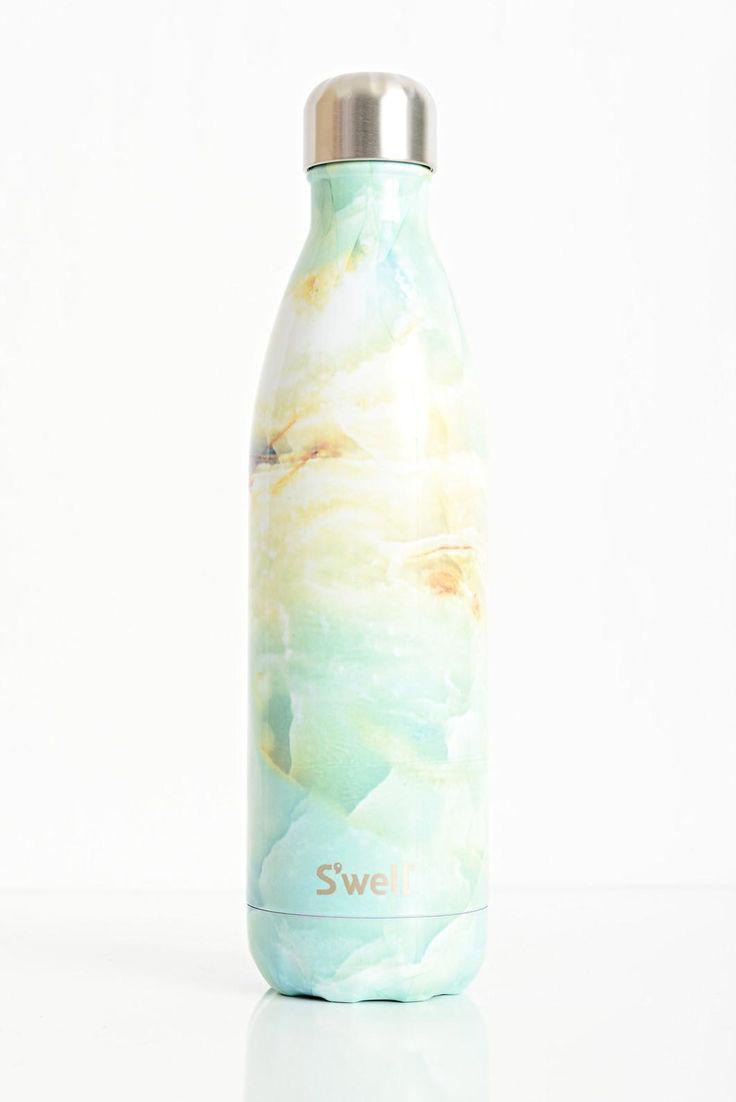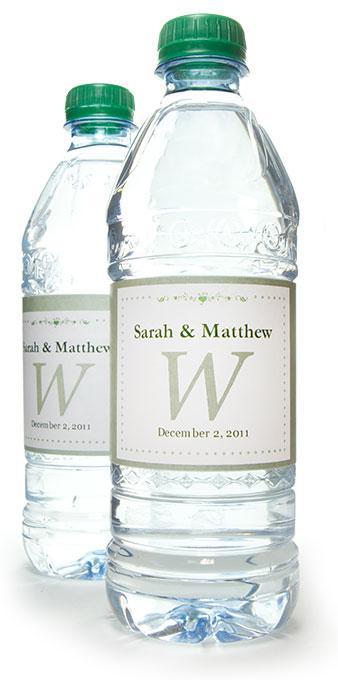The first image is the image on the left, the second image is the image on the right. Examine the images to the left and right. Is the description "In one image, three bottles have white caps and identical labels, while the second image has one or more bottles with dark caps and different labeling." accurate? Answer yes or no. No. The first image is the image on the left, the second image is the image on the right. Considering the images on both sides, is "The bottle on the left has a blue and white striped label and there are at least three bottles on the right hand image." valid? Answer yes or no. No. 